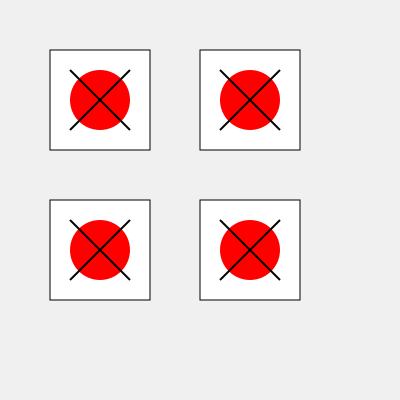Observe the four kimono pattern designs above. Which pattern would match the top-left design if rotated 90 degrees clockwise? To solve this problem, we need to mentally rotate the top-left kimono pattern 90 degrees clockwise and compare it with the other patterns. Let's follow these steps:

1. Identify the key elements of the top-left pattern:
   - A red circle in the center
   - Two intersecting lines forming an X shape

2. Mentally rotate the pattern 90 degrees clockwise:
   - The red circle remains in the center
   - The X shape rotates, with the lines now running from top-left to bottom-right and top-right to bottom-left

3. Compare the rotated image with the other three patterns:
   - Top-right pattern: The X shape is rotated 90 degrees counterclockwise, not clockwise
   - Bottom-left pattern: Identical to the original top-left pattern, no rotation
   - Bottom-right pattern: The X shape matches our mental rotation, with lines running from top-left to bottom-right and top-right to bottom-left

4. Conclude that the bottom-right pattern matches the top-left pattern when rotated 90 degrees clockwise.
Answer: Bottom-right pattern 